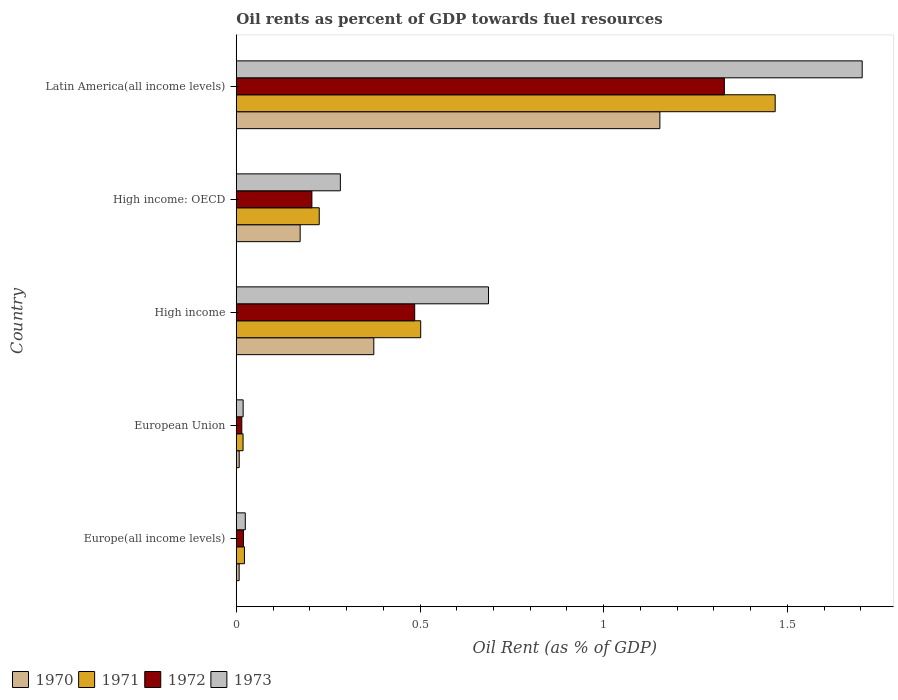How many different coloured bars are there?
Your response must be concise. 4. Are the number of bars on each tick of the Y-axis equal?
Your response must be concise. Yes. In how many cases, is the number of bars for a given country not equal to the number of legend labels?
Ensure brevity in your answer.  0. What is the oil rent in 1971 in Europe(all income levels)?
Your response must be concise. 0.02. Across all countries, what is the maximum oil rent in 1972?
Give a very brief answer. 1.33. Across all countries, what is the minimum oil rent in 1971?
Make the answer very short. 0.02. In which country was the oil rent in 1972 maximum?
Offer a terse response. Latin America(all income levels). In which country was the oil rent in 1972 minimum?
Offer a terse response. European Union. What is the total oil rent in 1971 in the graph?
Your response must be concise. 2.24. What is the difference between the oil rent in 1973 in High income: OECD and that in Latin America(all income levels)?
Keep it short and to the point. -1.42. What is the difference between the oil rent in 1970 in Latin America(all income levels) and the oil rent in 1973 in European Union?
Your response must be concise. 1.13. What is the average oil rent in 1971 per country?
Ensure brevity in your answer.  0.45. What is the difference between the oil rent in 1973 and oil rent in 1972 in High income: OECD?
Provide a succinct answer. 0.08. What is the ratio of the oil rent in 1972 in Europe(all income levels) to that in European Union?
Ensure brevity in your answer.  1.3. Is the difference between the oil rent in 1973 in Europe(all income levels) and Latin America(all income levels) greater than the difference between the oil rent in 1972 in Europe(all income levels) and Latin America(all income levels)?
Your answer should be very brief. No. What is the difference between the highest and the second highest oil rent in 1971?
Your answer should be compact. 0.96. What is the difference between the highest and the lowest oil rent in 1971?
Keep it short and to the point. 1.45. In how many countries, is the oil rent in 1972 greater than the average oil rent in 1972 taken over all countries?
Your answer should be very brief. 2. Is the sum of the oil rent in 1973 in High income and Latin America(all income levels) greater than the maximum oil rent in 1970 across all countries?
Your answer should be compact. Yes. Is it the case that in every country, the sum of the oil rent in 1972 and oil rent in 1971 is greater than the sum of oil rent in 1973 and oil rent in 1970?
Ensure brevity in your answer.  No. What does the 2nd bar from the top in High income represents?
Your answer should be compact. 1972. How many bars are there?
Keep it short and to the point. 20. What is the difference between two consecutive major ticks on the X-axis?
Your response must be concise. 0.5. Does the graph contain any zero values?
Your response must be concise. No. Does the graph contain grids?
Your answer should be compact. No. Where does the legend appear in the graph?
Ensure brevity in your answer.  Bottom left. What is the title of the graph?
Your answer should be compact. Oil rents as percent of GDP towards fuel resources. What is the label or title of the X-axis?
Offer a very short reply. Oil Rent (as % of GDP). What is the label or title of the Y-axis?
Your answer should be very brief. Country. What is the Oil Rent (as % of GDP) in 1970 in Europe(all income levels)?
Keep it short and to the point. 0.01. What is the Oil Rent (as % of GDP) in 1971 in Europe(all income levels)?
Offer a very short reply. 0.02. What is the Oil Rent (as % of GDP) of 1972 in Europe(all income levels)?
Make the answer very short. 0.02. What is the Oil Rent (as % of GDP) of 1973 in Europe(all income levels)?
Ensure brevity in your answer.  0.02. What is the Oil Rent (as % of GDP) in 1970 in European Union?
Provide a short and direct response. 0.01. What is the Oil Rent (as % of GDP) in 1971 in European Union?
Offer a very short reply. 0.02. What is the Oil Rent (as % of GDP) in 1972 in European Union?
Provide a short and direct response. 0.02. What is the Oil Rent (as % of GDP) of 1973 in European Union?
Keep it short and to the point. 0.02. What is the Oil Rent (as % of GDP) in 1970 in High income?
Offer a very short reply. 0.37. What is the Oil Rent (as % of GDP) in 1971 in High income?
Provide a short and direct response. 0.5. What is the Oil Rent (as % of GDP) in 1972 in High income?
Your response must be concise. 0.49. What is the Oil Rent (as % of GDP) in 1973 in High income?
Provide a short and direct response. 0.69. What is the Oil Rent (as % of GDP) in 1970 in High income: OECD?
Offer a very short reply. 0.17. What is the Oil Rent (as % of GDP) of 1971 in High income: OECD?
Provide a succinct answer. 0.23. What is the Oil Rent (as % of GDP) in 1972 in High income: OECD?
Offer a very short reply. 0.21. What is the Oil Rent (as % of GDP) in 1973 in High income: OECD?
Your response must be concise. 0.28. What is the Oil Rent (as % of GDP) in 1970 in Latin America(all income levels)?
Your answer should be compact. 1.15. What is the Oil Rent (as % of GDP) of 1971 in Latin America(all income levels)?
Your response must be concise. 1.47. What is the Oil Rent (as % of GDP) in 1972 in Latin America(all income levels)?
Ensure brevity in your answer.  1.33. What is the Oil Rent (as % of GDP) in 1973 in Latin America(all income levels)?
Ensure brevity in your answer.  1.7. Across all countries, what is the maximum Oil Rent (as % of GDP) of 1970?
Give a very brief answer. 1.15. Across all countries, what is the maximum Oil Rent (as % of GDP) of 1971?
Provide a succinct answer. 1.47. Across all countries, what is the maximum Oil Rent (as % of GDP) in 1972?
Provide a succinct answer. 1.33. Across all countries, what is the maximum Oil Rent (as % of GDP) of 1973?
Your answer should be very brief. 1.7. Across all countries, what is the minimum Oil Rent (as % of GDP) in 1970?
Ensure brevity in your answer.  0.01. Across all countries, what is the minimum Oil Rent (as % of GDP) of 1971?
Offer a very short reply. 0.02. Across all countries, what is the minimum Oil Rent (as % of GDP) of 1972?
Provide a short and direct response. 0.02. Across all countries, what is the minimum Oil Rent (as % of GDP) of 1973?
Offer a terse response. 0.02. What is the total Oil Rent (as % of GDP) in 1970 in the graph?
Make the answer very short. 1.72. What is the total Oil Rent (as % of GDP) of 1971 in the graph?
Your response must be concise. 2.24. What is the total Oil Rent (as % of GDP) of 1972 in the graph?
Make the answer very short. 2.05. What is the total Oil Rent (as % of GDP) in 1973 in the graph?
Provide a short and direct response. 2.72. What is the difference between the Oil Rent (as % of GDP) in 1970 in Europe(all income levels) and that in European Union?
Provide a short and direct response. -0. What is the difference between the Oil Rent (as % of GDP) of 1971 in Europe(all income levels) and that in European Union?
Ensure brevity in your answer.  0. What is the difference between the Oil Rent (as % of GDP) of 1972 in Europe(all income levels) and that in European Union?
Ensure brevity in your answer.  0. What is the difference between the Oil Rent (as % of GDP) in 1973 in Europe(all income levels) and that in European Union?
Make the answer very short. 0.01. What is the difference between the Oil Rent (as % of GDP) in 1970 in Europe(all income levels) and that in High income?
Give a very brief answer. -0.37. What is the difference between the Oil Rent (as % of GDP) in 1971 in Europe(all income levels) and that in High income?
Your answer should be very brief. -0.48. What is the difference between the Oil Rent (as % of GDP) of 1972 in Europe(all income levels) and that in High income?
Provide a succinct answer. -0.47. What is the difference between the Oil Rent (as % of GDP) of 1973 in Europe(all income levels) and that in High income?
Your answer should be very brief. -0.66. What is the difference between the Oil Rent (as % of GDP) of 1970 in Europe(all income levels) and that in High income: OECD?
Provide a short and direct response. -0.17. What is the difference between the Oil Rent (as % of GDP) of 1971 in Europe(all income levels) and that in High income: OECD?
Your answer should be very brief. -0.2. What is the difference between the Oil Rent (as % of GDP) in 1972 in Europe(all income levels) and that in High income: OECD?
Your answer should be compact. -0.19. What is the difference between the Oil Rent (as % of GDP) of 1973 in Europe(all income levels) and that in High income: OECD?
Provide a succinct answer. -0.26. What is the difference between the Oil Rent (as % of GDP) in 1970 in Europe(all income levels) and that in Latin America(all income levels)?
Offer a very short reply. -1.14. What is the difference between the Oil Rent (as % of GDP) in 1971 in Europe(all income levels) and that in Latin America(all income levels)?
Make the answer very short. -1.44. What is the difference between the Oil Rent (as % of GDP) in 1972 in Europe(all income levels) and that in Latin America(all income levels)?
Offer a terse response. -1.31. What is the difference between the Oil Rent (as % of GDP) in 1973 in Europe(all income levels) and that in Latin America(all income levels)?
Give a very brief answer. -1.68. What is the difference between the Oil Rent (as % of GDP) in 1970 in European Union and that in High income?
Keep it short and to the point. -0.37. What is the difference between the Oil Rent (as % of GDP) of 1971 in European Union and that in High income?
Provide a short and direct response. -0.48. What is the difference between the Oil Rent (as % of GDP) of 1972 in European Union and that in High income?
Keep it short and to the point. -0.47. What is the difference between the Oil Rent (as % of GDP) of 1973 in European Union and that in High income?
Keep it short and to the point. -0.67. What is the difference between the Oil Rent (as % of GDP) in 1970 in European Union and that in High income: OECD?
Offer a very short reply. -0.17. What is the difference between the Oil Rent (as % of GDP) of 1971 in European Union and that in High income: OECD?
Your answer should be very brief. -0.21. What is the difference between the Oil Rent (as % of GDP) in 1972 in European Union and that in High income: OECD?
Give a very brief answer. -0.19. What is the difference between the Oil Rent (as % of GDP) in 1973 in European Union and that in High income: OECD?
Your answer should be compact. -0.26. What is the difference between the Oil Rent (as % of GDP) of 1970 in European Union and that in Latin America(all income levels)?
Offer a very short reply. -1.14. What is the difference between the Oil Rent (as % of GDP) of 1971 in European Union and that in Latin America(all income levels)?
Your answer should be very brief. -1.45. What is the difference between the Oil Rent (as % of GDP) of 1972 in European Union and that in Latin America(all income levels)?
Keep it short and to the point. -1.31. What is the difference between the Oil Rent (as % of GDP) in 1973 in European Union and that in Latin America(all income levels)?
Your answer should be very brief. -1.68. What is the difference between the Oil Rent (as % of GDP) of 1970 in High income and that in High income: OECD?
Keep it short and to the point. 0.2. What is the difference between the Oil Rent (as % of GDP) in 1971 in High income and that in High income: OECD?
Offer a terse response. 0.28. What is the difference between the Oil Rent (as % of GDP) of 1972 in High income and that in High income: OECD?
Make the answer very short. 0.28. What is the difference between the Oil Rent (as % of GDP) in 1973 in High income and that in High income: OECD?
Keep it short and to the point. 0.4. What is the difference between the Oil Rent (as % of GDP) of 1970 in High income and that in Latin America(all income levels)?
Offer a terse response. -0.78. What is the difference between the Oil Rent (as % of GDP) of 1971 in High income and that in Latin America(all income levels)?
Give a very brief answer. -0.96. What is the difference between the Oil Rent (as % of GDP) in 1972 in High income and that in Latin America(all income levels)?
Your answer should be compact. -0.84. What is the difference between the Oil Rent (as % of GDP) of 1973 in High income and that in Latin America(all income levels)?
Ensure brevity in your answer.  -1.02. What is the difference between the Oil Rent (as % of GDP) of 1970 in High income: OECD and that in Latin America(all income levels)?
Make the answer very short. -0.98. What is the difference between the Oil Rent (as % of GDP) in 1971 in High income: OECD and that in Latin America(all income levels)?
Give a very brief answer. -1.24. What is the difference between the Oil Rent (as % of GDP) of 1972 in High income: OECD and that in Latin America(all income levels)?
Your response must be concise. -1.12. What is the difference between the Oil Rent (as % of GDP) in 1973 in High income: OECD and that in Latin America(all income levels)?
Offer a very short reply. -1.42. What is the difference between the Oil Rent (as % of GDP) of 1970 in Europe(all income levels) and the Oil Rent (as % of GDP) of 1971 in European Union?
Your response must be concise. -0.01. What is the difference between the Oil Rent (as % of GDP) of 1970 in Europe(all income levels) and the Oil Rent (as % of GDP) of 1972 in European Union?
Your response must be concise. -0.01. What is the difference between the Oil Rent (as % of GDP) of 1970 in Europe(all income levels) and the Oil Rent (as % of GDP) of 1973 in European Union?
Offer a terse response. -0.01. What is the difference between the Oil Rent (as % of GDP) of 1971 in Europe(all income levels) and the Oil Rent (as % of GDP) of 1972 in European Union?
Your response must be concise. 0.01. What is the difference between the Oil Rent (as % of GDP) in 1971 in Europe(all income levels) and the Oil Rent (as % of GDP) in 1973 in European Union?
Provide a succinct answer. 0. What is the difference between the Oil Rent (as % of GDP) of 1972 in Europe(all income levels) and the Oil Rent (as % of GDP) of 1973 in European Union?
Offer a very short reply. 0. What is the difference between the Oil Rent (as % of GDP) of 1970 in Europe(all income levels) and the Oil Rent (as % of GDP) of 1971 in High income?
Ensure brevity in your answer.  -0.49. What is the difference between the Oil Rent (as % of GDP) in 1970 in Europe(all income levels) and the Oil Rent (as % of GDP) in 1972 in High income?
Make the answer very short. -0.48. What is the difference between the Oil Rent (as % of GDP) of 1970 in Europe(all income levels) and the Oil Rent (as % of GDP) of 1973 in High income?
Make the answer very short. -0.68. What is the difference between the Oil Rent (as % of GDP) in 1971 in Europe(all income levels) and the Oil Rent (as % of GDP) in 1972 in High income?
Give a very brief answer. -0.46. What is the difference between the Oil Rent (as % of GDP) of 1971 in Europe(all income levels) and the Oil Rent (as % of GDP) of 1973 in High income?
Your response must be concise. -0.66. What is the difference between the Oil Rent (as % of GDP) of 1972 in Europe(all income levels) and the Oil Rent (as % of GDP) of 1973 in High income?
Offer a terse response. -0.67. What is the difference between the Oil Rent (as % of GDP) in 1970 in Europe(all income levels) and the Oil Rent (as % of GDP) in 1971 in High income: OECD?
Offer a terse response. -0.22. What is the difference between the Oil Rent (as % of GDP) in 1970 in Europe(all income levels) and the Oil Rent (as % of GDP) in 1972 in High income: OECD?
Provide a short and direct response. -0.2. What is the difference between the Oil Rent (as % of GDP) of 1970 in Europe(all income levels) and the Oil Rent (as % of GDP) of 1973 in High income: OECD?
Keep it short and to the point. -0.28. What is the difference between the Oil Rent (as % of GDP) in 1971 in Europe(all income levels) and the Oil Rent (as % of GDP) in 1972 in High income: OECD?
Keep it short and to the point. -0.18. What is the difference between the Oil Rent (as % of GDP) of 1971 in Europe(all income levels) and the Oil Rent (as % of GDP) of 1973 in High income: OECD?
Offer a very short reply. -0.26. What is the difference between the Oil Rent (as % of GDP) of 1972 in Europe(all income levels) and the Oil Rent (as % of GDP) of 1973 in High income: OECD?
Your answer should be compact. -0.26. What is the difference between the Oil Rent (as % of GDP) of 1970 in Europe(all income levels) and the Oil Rent (as % of GDP) of 1971 in Latin America(all income levels)?
Offer a very short reply. -1.46. What is the difference between the Oil Rent (as % of GDP) in 1970 in Europe(all income levels) and the Oil Rent (as % of GDP) in 1972 in Latin America(all income levels)?
Make the answer very short. -1.32. What is the difference between the Oil Rent (as % of GDP) of 1970 in Europe(all income levels) and the Oil Rent (as % of GDP) of 1973 in Latin America(all income levels)?
Your answer should be very brief. -1.7. What is the difference between the Oil Rent (as % of GDP) of 1971 in Europe(all income levels) and the Oil Rent (as % of GDP) of 1972 in Latin America(all income levels)?
Offer a terse response. -1.31. What is the difference between the Oil Rent (as % of GDP) of 1971 in Europe(all income levels) and the Oil Rent (as % of GDP) of 1973 in Latin America(all income levels)?
Give a very brief answer. -1.68. What is the difference between the Oil Rent (as % of GDP) of 1972 in Europe(all income levels) and the Oil Rent (as % of GDP) of 1973 in Latin America(all income levels)?
Your answer should be very brief. -1.68. What is the difference between the Oil Rent (as % of GDP) of 1970 in European Union and the Oil Rent (as % of GDP) of 1971 in High income?
Give a very brief answer. -0.49. What is the difference between the Oil Rent (as % of GDP) in 1970 in European Union and the Oil Rent (as % of GDP) in 1972 in High income?
Provide a short and direct response. -0.48. What is the difference between the Oil Rent (as % of GDP) in 1970 in European Union and the Oil Rent (as % of GDP) in 1973 in High income?
Your response must be concise. -0.68. What is the difference between the Oil Rent (as % of GDP) of 1971 in European Union and the Oil Rent (as % of GDP) of 1972 in High income?
Make the answer very short. -0.47. What is the difference between the Oil Rent (as % of GDP) of 1971 in European Union and the Oil Rent (as % of GDP) of 1973 in High income?
Offer a very short reply. -0.67. What is the difference between the Oil Rent (as % of GDP) of 1972 in European Union and the Oil Rent (as % of GDP) of 1973 in High income?
Offer a very short reply. -0.67. What is the difference between the Oil Rent (as % of GDP) in 1970 in European Union and the Oil Rent (as % of GDP) in 1971 in High income: OECD?
Provide a succinct answer. -0.22. What is the difference between the Oil Rent (as % of GDP) in 1970 in European Union and the Oil Rent (as % of GDP) in 1972 in High income: OECD?
Make the answer very short. -0.2. What is the difference between the Oil Rent (as % of GDP) in 1970 in European Union and the Oil Rent (as % of GDP) in 1973 in High income: OECD?
Provide a short and direct response. -0.28. What is the difference between the Oil Rent (as % of GDP) of 1971 in European Union and the Oil Rent (as % of GDP) of 1972 in High income: OECD?
Offer a very short reply. -0.19. What is the difference between the Oil Rent (as % of GDP) of 1971 in European Union and the Oil Rent (as % of GDP) of 1973 in High income: OECD?
Give a very brief answer. -0.26. What is the difference between the Oil Rent (as % of GDP) of 1972 in European Union and the Oil Rent (as % of GDP) of 1973 in High income: OECD?
Keep it short and to the point. -0.27. What is the difference between the Oil Rent (as % of GDP) in 1970 in European Union and the Oil Rent (as % of GDP) in 1971 in Latin America(all income levels)?
Your answer should be very brief. -1.46. What is the difference between the Oil Rent (as % of GDP) in 1970 in European Union and the Oil Rent (as % of GDP) in 1972 in Latin America(all income levels)?
Your answer should be very brief. -1.32. What is the difference between the Oil Rent (as % of GDP) of 1970 in European Union and the Oil Rent (as % of GDP) of 1973 in Latin America(all income levels)?
Your response must be concise. -1.7. What is the difference between the Oil Rent (as % of GDP) in 1971 in European Union and the Oil Rent (as % of GDP) in 1972 in Latin America(all income levels)?
Your answer should be compact. -1.31. What is the difference between the Oil Rent (as % of GDP) of 1971 in European Union and the Oil Rent (as % of GDP) of 1973 in Latin America(all income levels)?
Offer a terse response. -1.68. What is the difference between the Oil Rent (as % of GDP) of 1972 in European Union and the Oil Rent (as % of GDP) of 1973 in Latin America(all income levels)?
Your answer should be very brief. -1.69. What is the difference between the Oil Rent (as % of GDP) of 1970 in High income and the Oil Rent (as % of GDP) of 1971 in High income: OECD?
Ensure brevity in your answer.  0.15. What is the difference between the Oil Rent (as % of GDP) of 1970 in High income and the Oil Rent (as % of GDP) of 1972 in High income: OECD?
Ensure brevity in your answer.  0.17. What is the difference between the Oil Rent (as % of GDP) in 1970 in High income and the Oil Rent (as % of GDP) in 1973 in High income: OECD?
Your answer should be very brief. 0.09. What is the difference between the Oil Rent (as % of GDP) in 1971 in High income and the Oil Rent (as % of GDP) in 1972 in High income: OECD?
Provide a short and direct response. 0.3. What is the difference between the Oil Rent (as % of GDP) of 1971 in High income and the Oil Rent (as % of GDP) of 1973 in High income: OECD?
Your response must be concise. 0.22. What is the difference between the Oil Rent (as % of GDP) of 1972 in High income and the Oil Rent (as % of GDP) of 1973 in High income: OECD?
Your answer should be very brief. 0.2. What is the difference between the Oil Rent (as % of GDP) of 1970 in High income and the Oil Rent (as % of GDP) of 1971 in Latin America(all income levels)?
Your answer should be very brief. -1.09. What is the difference between the Oil Rent (as % of GDP) in 1970 in High income and the Oil Rent (as % of GDP) in 1972 in Latin America(all income levels)?
Give a very brief answer. -0.95. What is the difference between the Oil Rent (as % of GDP) of 1970 in High income and the Oil Rent (as % of GDP) of 1973 in Latin America(all income levels)?
Offer a terse response. -1.33. What is the difference between the Oil Rent (as % of GDP) in 1971 in High income and the Oil Rent (as % of GDP) in 1972 in Latin America(all income levels)?
Ensure brevity in your answer.  -0.83. What is the difference between the Oil Rent (as % of GDP) of 1971 in High income and the Oil Rent (as % of GDP) of 1973 in Latin America(all income levels)?
Keep it short and to the point. -1.2. What is the difference between the Oil Rent (as % of GDP) of 1972 in High income and the Oil Rent (as % of GDP) of 1973 in Latin America(all income levels)?
Provide a short and direct response. -1.22. What is the difference between the Oil Rent (as % of GDP) in 1970 in High income: OECD and the Oil Rent (as % of GDP) in 1971 in Latin America(all income levels)?
Provide a succinct answer. -1.29. What is the difference between the Oil Rent (as % of GDP) of 1970 in High income: OECD and the Oil Rent (as % of GDP) of 1972 in Latin America(all income levels)?
Keep it short and to the point. -1.15. What is the difference between the Oil Rent (as % of GDP) in 1970 in High income: OECD and the Oil Rent (as % of GDP) in 1973 in Latin America(all income levels)?
Offer a terse response. -1.53. What is the difference between the Oil Rent (as % of GDP) of 1971 in High income: OECD and the Oil Rent (as % of GDP) of 1972 in Latin America(all income levels)?
Your answer should be compact. -1.1. What is the difference between the Oil Rent (as % of GDP) in 1971 in High income: OECD and the Oil Rent (as % of GDP) in 1973 in Latin America(all income levels)?
Your answer should be very brief. -1.48. What is the difference between the Oil Rent (as % of GDP) in 1972 in High income: OECD and the Oil Rent (as % of GDP) in 1973 in Latin America(all income levels)?
Your answer should be compact. -1.5. What is the average Oil Rent (as % of GDP) of 1970 per country?
Offer a terse response. 0.34. What is the average Oil Rent (as % of GDP) of 1971 per country?
Give a very brief answer. 0.45. What is the average Oil Rent (as % of GDP) in 1972 per country?
Your answer should be very brief. 0.41. What is the average Oil Rent (as % of GDP) in 1973 per country?
Offer a very short reply. 0.54. What is the difference between the Oil Rent (as % of GDP) of 1970 and Oil Rent (as % of GDP) of 1971 in Europe(all income levels)?
Make the answer very short. -0.01. What is the difference between the Oil Rent (as % of GDP) of 1970 and Oil Rent (as % of GDP) of 1972 in Europe(all income levels)?
Your response must be concise. -0.01. What is the difference between the Oil Rent (as % of GDP) of 1970 and Oil Rent (as % of GDP) of 1973 in Europe(all income levels)?
Keep it short and to the point. -0.02. What is the difference between the Oil Rent (as % of GDP) of 1971 and Oil Rent (as % of GDP) of 1972 in Europe(all income levels)?
Offer a terse response. 0. What is the difference between the Oil Rent (as % of GDP) in 1971 and Oil Rent (as % of GDP) in 1973 in Europe(all income levels)?
Keep it short and to the point. -0. What is the difference between the Oil Rent (as % of GDP) of 1972 and Oil Rent (as % of GDP) of 1973 in Europe(all income levels)?
Offer a very short reply. -0.01. What is the difference between the Oil Rent (as % of GDP) in 1970 and Oil Rent (as % of GDP) in 1971 in European Union?
Make the answer very short. -0.01. What is the difference between the Oil Rent (as % of GDP) of 1970 and Oil Rent (as % of GDP) of 1972 in European Union?
Keep it short and to the point. -0.01. What is the difference between the Oil Rent (as % of GDP) of 1970 and Oil Rent (as % of GDP) of 1973 in European Union?
Your answer should be compact. -0.01. What is the difference between the Oil Rent (as % of GDP) in 1971 and Oil Rent (as % of GDP) in 1972 in European Union?
Your answer should be compact. 0. What is the difference between the Oil Rent (as % of GDP) in 1971 and Oil Rent (as % of GDP) in 1973 in European Union?
Provide a short and direct response. -0. What is the difference between the Oil Rent (as % of GDP) in 1972 and Oil Rent (as % of GDP) in 1973 in European Union?
Keep it short and to the point. -0. What is the difference between the Oil Rent (as % of GDP) in 1970 and Oil Rent (as % of GDP) in 1971 in High income?
Offer a terse response. -0.13. What is the difference between the Oil Rent (as % of GDP) of 1970 and Oil Rent (as % of GDP) of 1972 in High income?
Your answer should be very brief. -0.11. What is the difference between the Oil Rent (as % of GDP) in 1970 and Oil Rent (as % of GDP) in 1973 in High income?
Give a very brief answer. -0.31. What is the difference between the Oil Rent (as % of GDP) of 1971 and Oil Rent (as % of GDP) of 1972 in High income?
Provide a succinct answer. 0.02. What is the difference between the Oil Rent (as % of GDP) of 1971 and Oil Rent (as % of GDP) of 1973 in High income?
Your answer should be compact. -0.18. What is the difference between the Oil Rent (as % of GDP) of 1972 and Oil Rent (as % of GDP) of 1973 in High income?
Your response must be concise. -0.2. What is the difference between the Oil Rent (as % of GDP) of 1970 and Oil Rent (as % of GDP) of 1971 in High income: OECD?
Provide a short and direct response. -0.05. What is the difference between the Oil Rent (as % of GDP) in 1970 and Oil Rent (as % of GDP) in 1972 in High income: OECD?
Provide a short and direct response. -0.03. What is the difference between the Oil Rent (as % of GDP) in 1970 and Oil Rent (as % of GDP) in 1973 in High income: OECD?
Your answer should be compact. -0.11. What is the difference between the Oil Rent (as % of GDP) of 1971 and Oil Rent (as % of GDP) of 1973 in High income: OECD?
Your answer should be compact. -0.06. What is the difference between the Oil Rent (as % of GDP) in 1972 and Oil Rent (as % of GDP) in 1973 in High income: OECD?
Provide a succinct answer. -0.08. What is the difference between the Oil Rent (as % of GDP) in 1970 and Oil Rent (as % of GDP) in 1971 in Latin America(all income levels)?
Ensure brevity in your answer.  -0.31. What is the difference between the Oil Rent (as % of GDP) in 1970 and Oil Rent (as % of GDP) in 1972 in Latin America(all income levels)?
Make the answer very short. -0.18. What is the difference between the Oil Rent (as % of GDP) in 1970 and Oil Rent (as % of GDP) in 1973 in Latin America(all income levels)?
Offer a terse response. -0.55. What is the difference between the Oil Rent (as % of GDP) of 1971 and Oil Rent (as % of GDP) of 1972 in Latin America(all income levels)?
Your answer should be compact. 0.14. What is the difference between the Oil Rent (as % of GDP) of 1971 and Oil Rent (as % of GDP) of 1973 in Latin America(all income levels)?
Ensure brevity in your answer.  -0.24. What is the difference between the Oil Rent (as % of GDP) of 1972 and Oil Rent (as % of GDP) of 1973 in Latin America(all income levels)?
Your answer should be compact. -0.38. What is the ratio of the Oil Rent (as % of GDP) in 1970 in Europe(all income levels) to that in European Union?
Offer a very short reply. 0.98. What is the ratio of the Oil Rent (as % of GDP) of 1971 in Europe(all income levels) to that in European Union?
Provide a succinct answer. 1.2. What is the ratio of the Oil Rent (as % of GDP) of 1972 in Europe(all income levels) to that in European Union?
Ensure brevity in your answer.  1.3. What is the ratio of the Oil Rent (as % of GDP) in 1973 in Europe(all income levels) to that in European Union?
Provide a succinct answer. 1.31. What is the ratio of the Oil Rent (as % of GDP) of 1970 in Europe(all income levels) to that in High income?
Provide a short and direct response. 0.02. What is the ratio of the Oil Rent (as % of GDP) in 1971 in Europe(all income levels) to that in High income?
Provide a short and direct response. 0.04. What is the ratio of the Oil Rent (as % of GDP) in 1972 in Europe(all income levels) to that in High income?
Your response must be concise. 0.04. What is the ratio of the Oil Rent (as % of GDP) of 1973 in Europe(all income levels) to that in High income?
Give a very brief answer. 0.04. What is the ratio of the Oil Rent (as % of GDP) of 1970 in Europe(all income levels) to that in High income: OECD?
Provide a short and direct response. 0.05. What is the ratio of the Oil Rent (as % of GDP) of 1971 in Europe(all income levels) to that in High income: OECD?
Your response must be concise. 0.1. What is the ratio of the Oil Rent (as % of GDP) of 1972 in Europe(all income levels) to that in High income: OECD?
Offer a terse response. 0.1. What is the ratio of the Oil Rent (as % of GDP) of 1973 in Europe(all income levels) to that in High income: OECD?
Offer a very short reply. 0.09. What is the ratio of the Oil Rent (as % of GDP) in 1970 in Europe(all income levels) to that in Latin America(all income levels)?
Provide a succinct answer. 0.01. What is the ratio of the Oil Rent (as % of GDP) of 1971 in Europe(all income levels) to that in Latin America(all income levels)?
Offer a very short reply. 0.02. What is the ratio of the Oil Rent (as % of GDP) of 1972 in Europe(all income levels) to that in Latin America(all income levels)?
Your answer should be very brief. 0.01. What is the ratio of the Oil Rent (as % of GDP) in 1973 in Europe(all income levels) to that in Latin America(all income levels)?
Your response must be concise. 0.01. What is the ratio of the Oil Rent (as % of GDP) of 1970 in European Union to that in High income?
Your answer should be very brief. 0.02. What is the ratio of the Oil Rent (as % of GDP) of 1971 in European Union to that in High income?
Give a very brief answer. 0.04. What is the ratio of the Oil Rent (as % of GDP) of 1972 in European Union to that in High income?
Provide a short and direct response. 0.03. What is the ratio of the Oil Rent (as % of GDP) of 1973 in European Union to that in High income?
Your response must be concise. 0.03. What is the ratio of the Oil Rent (as % of GDP) in 1970 in European Union to that in High income: OECD?
Keep it short and to the point. 0.05. What is the ratio of the Oil Rent (as % of GDP) of 1971 in European Union to that in High income: OECD?
Provide a short and direct response. 0.08. What is the ratio of the Oil Rent (as % of GDP) of 1972 in European Union to that in High income: OECD?
Give a very brief answer. 0.07. What is the ratio of the Oil Rent (as % of GDP) in 1973 in European Union to that in High income: OECD?
Your response must be concise. 0.07. What is the ratio of the Oil Rent (as % of GDP) in 1970 in European Union to that in Latin America(all income levels)?
Make the answer very short. 0.01. What is the ratio of the Oil Rent (as % of GDP) of 1971 in European Union to that in Latin America(all income levels)?
Your answer should be very brief. 0.01. What is the ratio of the Oil Rent (as % of GDP) of 1972 in European Union to that in Latin America(all income levels)?
Your answer should be very brief. 0.01. What is the ratio of the Oil Rent (as % of GDP) in 1973 in European Union to that in Latin America(all income levels)?
Your answer should be compact. 0.01. What is the ratio of the Oil Rent (as % of GDP) of 1970 in High income to that in High income: OECD?
Offer a very short reply. 2.15. What is the ratio of the Oil Rent (as % of GDP) of 1971 in High income to that in High income: OECD?
Keep it short and to the point. 2.22. What is the ratio of the Oil Rent (as % of GDP) of 1972 in High income to that in High income: OECD?
Make the answer very short. 2.36. What is the ratio of the Oil Rent (as % of GDP) of 1973 in High income to that in High income: OECD?
Your response must be concise. 2.42. What is the ratio of the Oil Rent (as % of GDP) in 1970 in High income to that in Latin America(all income levels)?
Your answer should be compact. 0.32. What is the ratio of the Oil Rent (as % of GDP) of 1971 in High income to that in Latin America(all income levels)?
Keep it short and to the point. 0.34. What is the ratio of the Oil Rent (as % of GDP) in 1972 in High income to that in Latin America(all income levels)?
Your response must be concise. 0.37. What is the ratio of the Oil Rent (as % of GDP) in 1973 in High income to that in Latin America(all income levels)?
Ensure brevity in your answer.  0.4. What is the ratio of the Oil Rent (as % of GDP) in 1970 in High income: OECD to that in Latin America(all income levels)?
Your response must be concise. 0.15. What is the ratio of the Oil Rent (as % of GDP) in 1971 in High income: OECD to that in Latin America(all income levels)?
Your answer should be very brief. 0.15. What is the ratio of the Oil Rent (as % of GDP) in 1972 in High income: OECD to that in Latin America(all income levels)?
Your answer should be compact. 0.15. What is the ratio of the Oil Rent (as % of GDP) of 1973 in High income: OECD to that in Latin America(all income levels)?
Ensure brevity in your answer.  0.17. What is the difference between the highest and the second highest Oil Rent (as % of GDP) of 1970?
Provide a short and direct response. 0.78. What is the difference between the highest and the second highest Oil Rent (as % of GDP) of 1971?
Offer a terse response. 0.96. What is the difference between the highest and the second highest Oil Rent (as % of GDP) of 1972?
Your answer should be very brief. 0.84. What is the difference between the highest and the second highest Oil Rent (as % of GDP) in 1973?
Make the answer very short. 1.02. What is the difference between the highest and the lowest Oil Rent (as % of GDP) of 1970?
Give a very brief answer. 1.14. What is the difference between the highest and the lowest Oil Rent (as % of GDP) in 1971?
Your response must be concise. 1.45. What is the difference between the highest and the lowest Oil Rent (as % of GDP) of 1972?
Provide a short and direct response. 1.31. What is the difference between the highest and the lowest Oil Rent (as % of GDP) of 1973?
Provide a succinct answer. 1.68. 